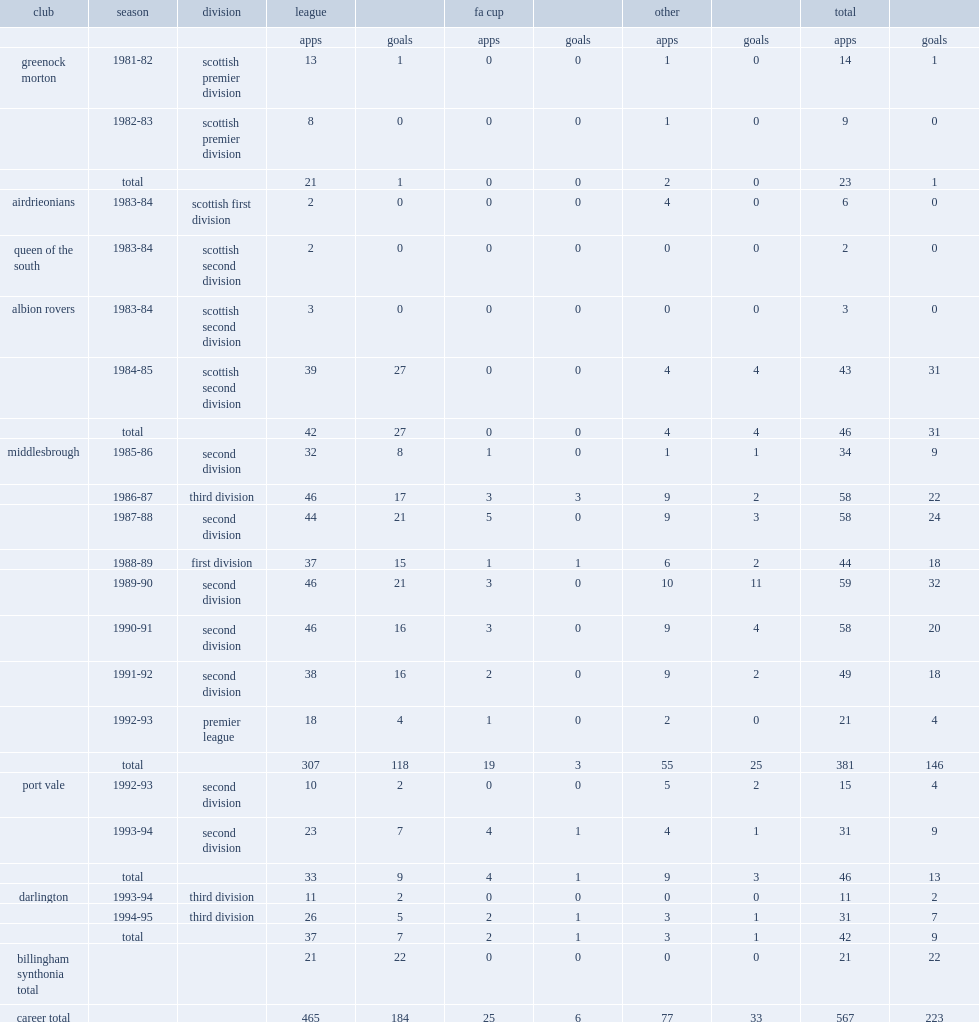Could you help me parse every detail presented in this table? {'header': ['club', 'season', 'division', 'league', '', 'fa cup', '', 'other', '', 'total', ''], 'rows': [['', '', '', 'apps', 'goals', 'apps', 'goals', 'apps', 'goals', 'apps', 'goals'], ['greenock morton', '1981-82', 'scottish premier division', '13', '1', '0', '0', '1', '0', '14', '1'], ['', '1982-83', 'scottish premier division', '8', '0', '0', '0', '1', '0', '9', '0'], ['', 'total', '', '21', '1', '0', '0', '2', '0', '23', '1'], ['airdrieonians', '1983-84', 'scottish first division', '2', '0', '0', '0', '4', '0', '6', '0'], ['queen of the south', '1983-84', 'scottish second division', '2', '0', '0', '0', '0', '0', '2', '0'], ['albion rovers', '1983-84', 'scottish second division', '3', '0', '0', '0', '0', '0', '3', '0'], ['', '1984-85', 'scottish second division', '39', '27', '0', '0', '4', '4', '43', '31'], ['', 'total', '', '42', '27', '0', '0', '4', '4', '46', '31'], ['middlesbrough', '1985-86', 'second division', '32', '8', '1', '0', '1', '1', '34', '9'], ['', '1986-87', 'third division', '46', '17', '3', '3', '9', '2', '58', '22'], ['', '1987-88', 'second division', '44', '21', '5', '0', '9', '3', '58', '24'], ['', '1988-89', 'first division', '37', '15', '1', '1', '6', '2', '44', '18'], ['', '1989-90', 'second division', '46', '21', '3', '0', '10', '11', '59', '32'], ['', '1990-91', 'second division', '46', '16', '3', '0', '9', '4', '58', '20'], ['', '1991-92', 'second division', '38', '16', '2', '0', '9', '2', '49', '18'], ['', '1992-93', 'premier league', '18', '4', '1', '0', '2', '0', '21', '4'], ['', 'total', '', '307', '118', '19', '3', '55', '25', '381', '146'], ['port vale', '1992-93', 'second division', '10', '2', '0', '0', '5', '2', '15', '4'], ['', '1993-94', 'second division', '23', '7', '4', '1', '4', '1', '31', '9'], ['', 'total', '', '33', '9', '4', '1', '9', '3', '46', '13'], ['darlington', '1993-94', 'third division', '11', '2', '0', '0', '0', '0', '11', '2'], ['', '1994-95', 'third division', '26', '5', '2', '1', '3', '1', '31', '7'], ['', 'total', '', '37', '7', '2', '1', '3', '1', '42', '9'], ['billingham synthonia total', '', '', '21', '22', '0', '0', '0', '0', '21', '22'], ['career total', '', '', '465', '184', '25', '6', '77', '33', '567', '223']]} How many goals did bernie slaven score in his career totally? 223.0. 